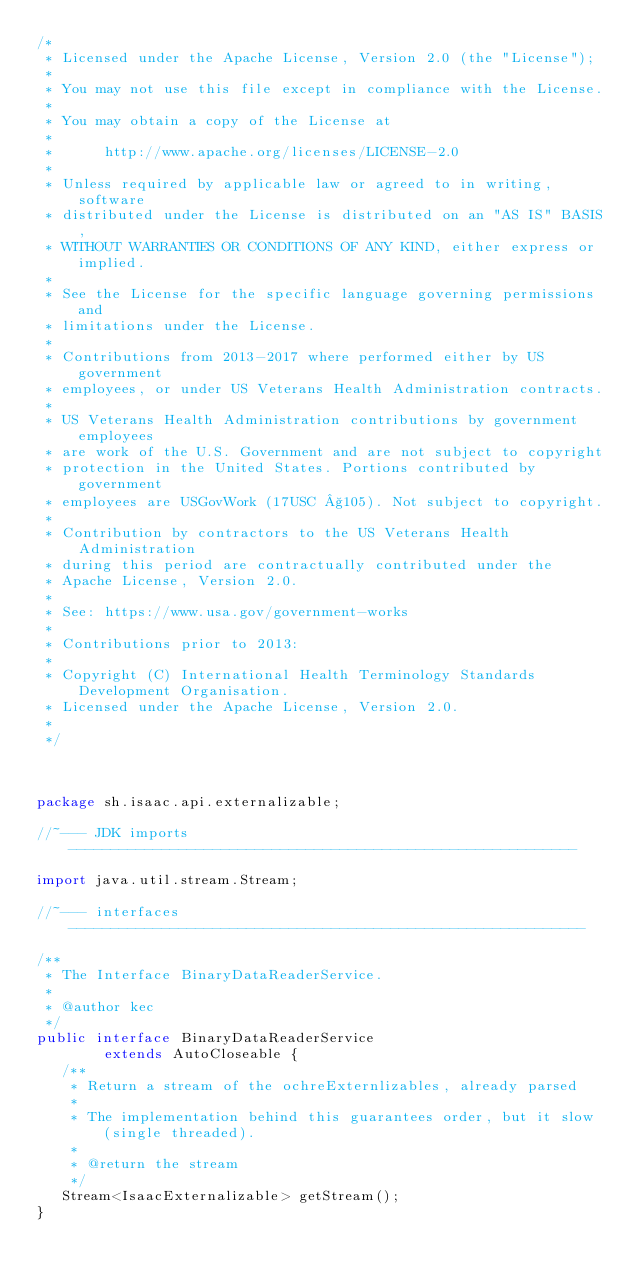Convert code to text. <code><loc_0><loc_0><loc_500><loc_500><_Java_>/* 
 * Licensed under the Apache License, Version 2.0 (the "License");
 *
 * You may not use this file except in compliance with the License.
 *
 * You may obtain a copy of the License at
 *
 *      http://www.apache.org/licenses/LICENSE-2.0
 *
 * Unless required by applicable law or agreed to in writing, software
 * distributed under the License is distributed on an "AS IS" BASIS,
 * WITHOUT WARRANTIES OR CONDITIONS OF ANY KIND, either express or implied.
 *
 * See the License for the specific language governing permissions and
 * limitations under the License.
 *
 * Contributions from 2013-2017 where performed either by US government 
 * employees, or under US Veterans Health Administration contracts. 
 *
 * US Veterans Health Administration contributions by government employees
 * are work of the U.S. Government and are not subject to copyright
 * protection in the United States. Portions contributed by government 
 * employees are USGovWork (17USC §105). Not subject to copyright. 
 * 
 * Contribution by contractors to the US Veterans Health Administration
 * during this period are contractually contributed under the
 * Apache License, Version 2.0.
 *
 * See: https://www.usa.gov/government-works
 * 
 * Contributions prior to 2013:
 *
 * Copyright (C) International Health Terminology Standards Development Organisation.
 * Licensed under the Apache License, Version 2.0.
 *
 */



package sh.isaac.api.externalizable;

//~--- JDK imports ------------------------------------------------------------

import java.util.stream.Stream;

//~--- interfaces -------------------------------------------------------------

/**
 * The Interface BinaryDataReaderService.
 *
 * @author kec
 */
public interface BinaryDataReaderService
        extends AutoCloseable {
   /**
    * Return a stream of the ochreExternlizables, already parsed
    *
    * The implementation behind this guarantees order, but it slow (single threaded).
    *
    * @return the stream
    */
   Stream<IsaacExternalizable> getStream();
}

</code> 